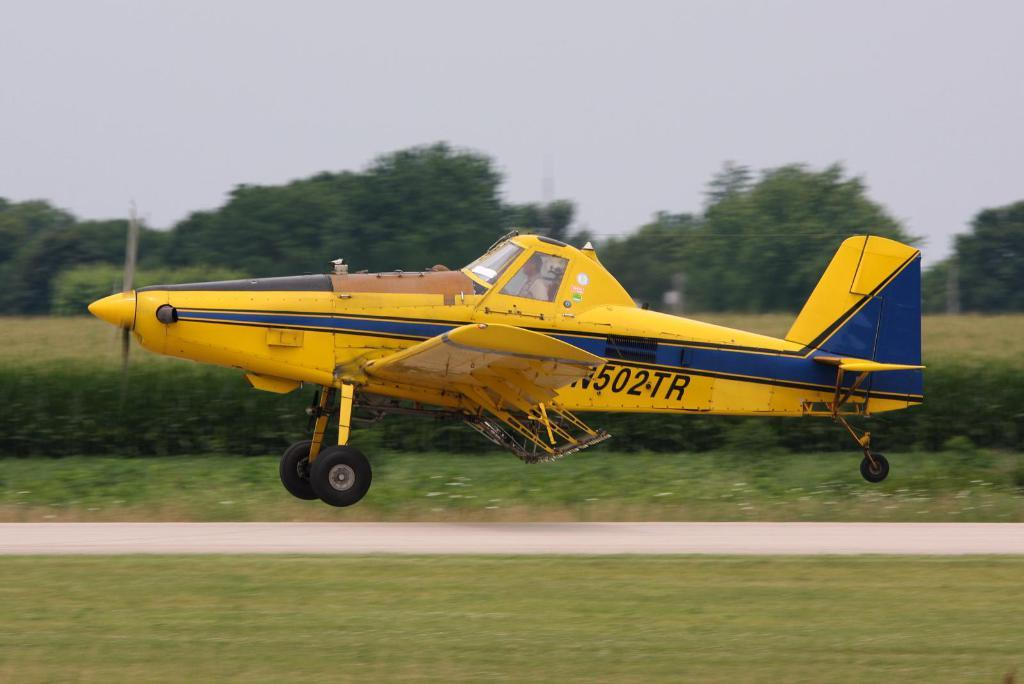What is the main subject in the center of the image? There is an aeroplane in the center of the image. What type of terrain is visible at the bottom of the image? There is grass at the bottom of the image. What can be seen in the background of the image? There are trees and the sky visible in the background of the image. What type of ice can be seen melting on the wings of the aeroplane in the image? There is no ice visible on the wings of the aeroplane in the image. Can you hear the voice of the pilot in the image? The image is a still picture and does not contain any sound, so it is not possible to hear the voice of the pilot. 